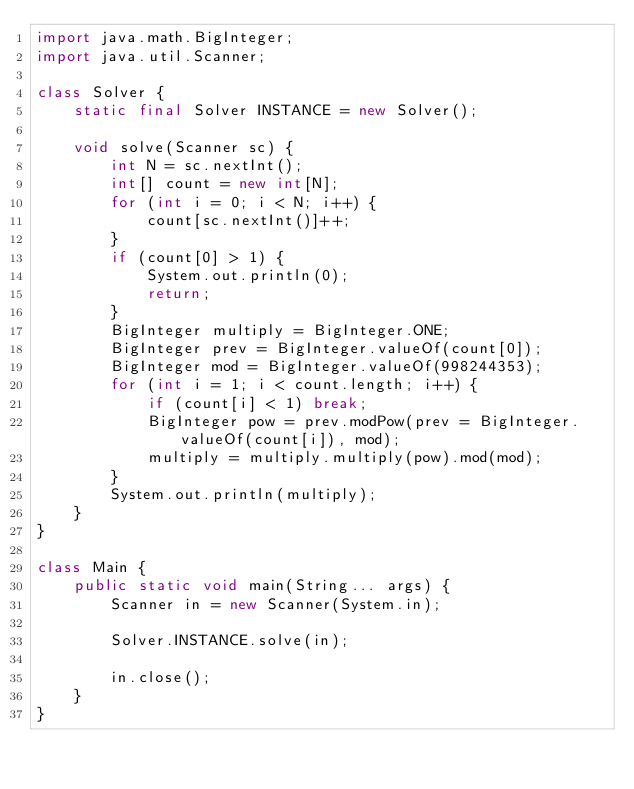<code> <loc_0><loc_0><loc_500><loc_500><_Java_>import java.math.BigInteger;
import java.util.Scanner;

class Solver {
	static final Solver INSTANCE = new Solver();

	void solve(Scanner sc) {
		int N = sc.nextInt();
		int[] count = new int[N];
		for (int i = 0; i < N; i++) {
			count[sc.nextInt()]++;
		}
		if (count[0] > 1) {
			System.out.println(0);
			return;
		}
		BigInteger multiply = BigInteger.ONE;
		BigInteger prev = BigInteger.valueOf(count[0]);
		BigInteger mod = BigInteger.valueOf(998244353);
		for (int i = 1; i < count.length; i++) {
			if (count[i] < 1) break;
			BigInteger pow = prev.modPow(prev = BigInteger.valueOf(count[i]), mod);
			multiply = multiply.multiply(pow).mod(mod);
		}
		System.out.println(multiply);
	}
}

class Main {
	public static void main(String... args) {
		Scanner in = new Scanner(System.in);

		Solver.INSTANCE.solve(in);

		in.close();
	}
}</code> 